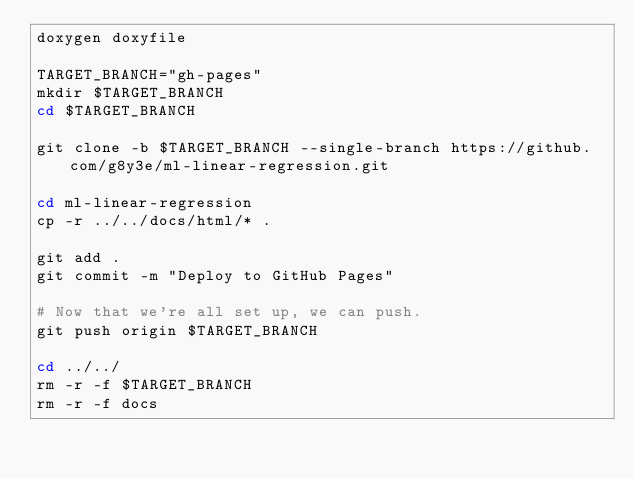Convert code to text. <code><loc_0><loc_0><loc_500><loc_500><_Bash_>doxygen doxyfile

TARGET_BRANCH="gh-pages"
mkdir $TARGET_BRANCH
cd $TARGET_BRANCH
 
git clone -b $TARGET_BRANCH --single-branch https://github.com/g8y3e/ml-linear-regression.git

cd ml-linear-regression
cp -r ../../docs/html/* .

git add .
git commit -m "Deploy to GitHub Pages"

# Now that we're all set up, we can push.
git push origin $TARGET_BRANCH

cd ../../
rm -r -f $TARGET_BRANCH
rm -r -f docs</code> 